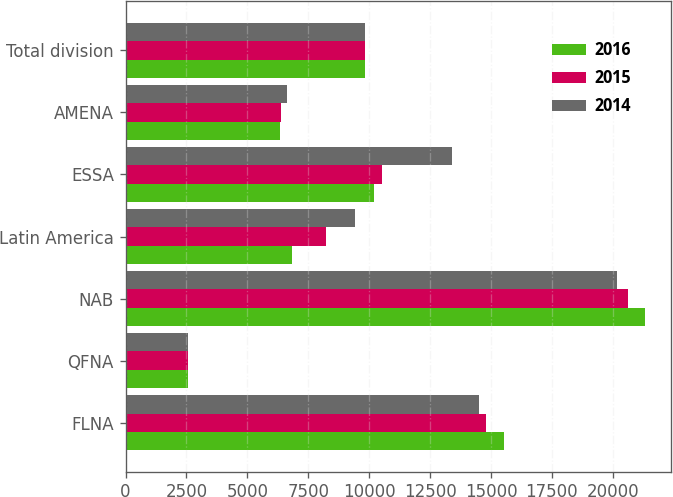Convert chart to OTSL. <chart><loc_0><loc_0><loc_500><loc_500><stacked_bar_chart><ecel><fcel>FLNA<fcel>QFNA<fcel>NAB<fcel>Latin America<fcel>ESSA<fcel>AMENA<fcel>Total division<nl><fcel>2016<fcel>15549<fcel>2564<fcel>21312<fcel>6820<fcel>10216<fcel>6338<fcel>9820.5<nl><fcel>2015<fcel>14782<fcel>2543<fcel>20618<fcel>8228<fcel>10510<fcel>6375<fcel>9820.5<nl><fcel>2014<fcel>14502<fcel>2568<fcel>20171<fcel>9425<fcel>13399<fcel>6618<fcel>9820.5<nl></chart> 